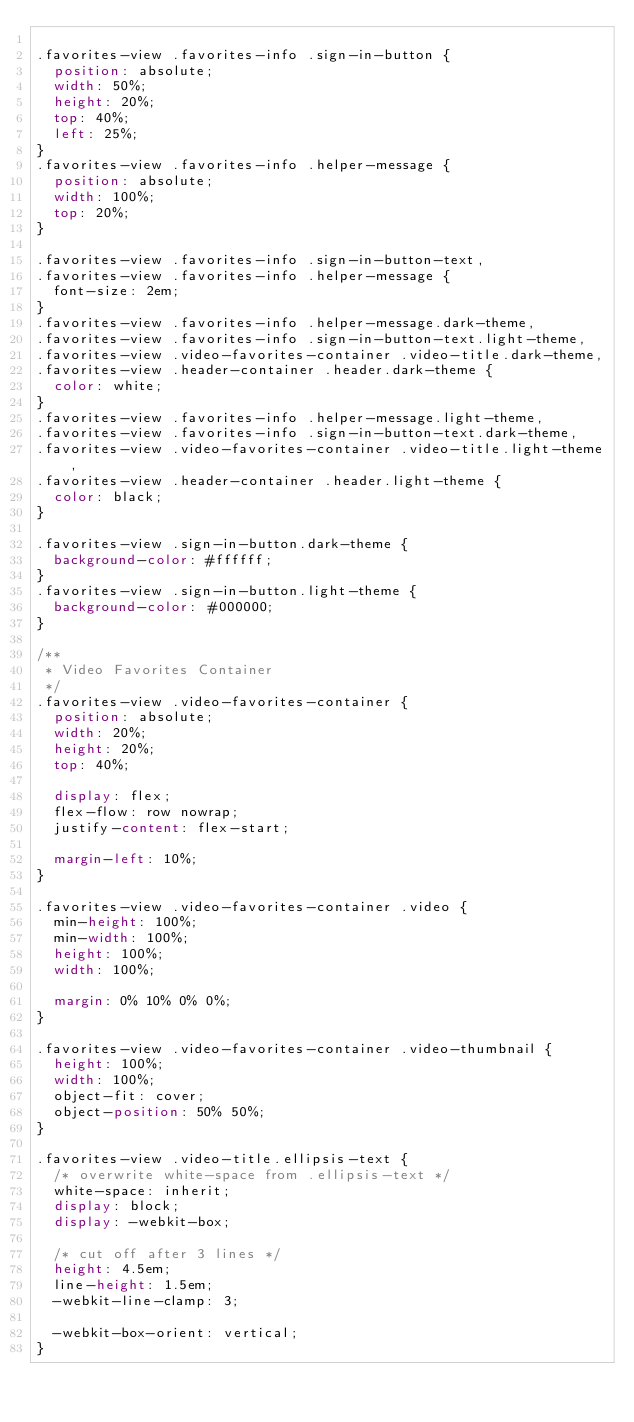Convert code to text. <code><loc_0><loc_0><loc_500><loc_500><_CSS_>
.favorites-view .favorites-info .sign-in-button {
  position: absolute;
  width: 50%;
  height: 20%;
  top: 40%;
  left: 25%;
}
.favorites-view .favorites-info .helper-message {
  position: absolute;
  width: 100%;
  top: 20%;
}

.favorites-view .favorites-info .sign-in-button-text,
.favorites-view .favorites-info .helper-message {
  font-size: 2em;
}
.favorites-view .favorites-info .helper-message.dark-theme,
.favorites-view .favorites-info .sign-in-button-text.light-theme,
.favorites-view .video-favorites-container .video-title.dark-theme,
.favorites-view .header-container .header.dark-theme {
  color: white;
}
.favorites-view .favorites-info .helper-message.light-theme,
.favorites-view .favorites-info .sign-in-button-text.dark-theme,
.favorites-view .video-favorites-container .video-title.light-theme,
.favorites-view .header-container .header.light-theme {
  color: black;
}

.favorites-view .sign-in-button.dark-theme {
  background-color: #ffffff;
}
.favorites-view .sign-in-button.light-theme {
  background-color: #000000;
}

/**
 * Video Favorites Container
 */
.favorites-view .video-favorites-container {
  position: absolute;
  width: 20%;
  height: 20%;
  top: 40%;

  display: flex;
  flex-flow: row nowrap;
  justify-content: flex-start;

  margin-left: 10%;
}

.favorites-view .video-favorites-container .video {
  min-height: 100%;
  min-width: 100%;
  height: 100%;
  width: 100%;

  margin: 0% 10% 0% 0%;
}

.favorites-view .video-favorites-container .video-thumbnail {
  height: 100%;
  width: 100%;
  object-fit: cover;
  object-position: 50% 50%;
}

.favorites-view .video-title.ellipsis-text {
  /* overwrite white-space from .ellipsis-text */
  white-space: inherit;
  display: block;
  display: -webkit-box;

  /* cut off after 3 lines */
  height: 4.5em;
  line-height: 1.5em;
  -webkit-line-clamp: 3;

  -webkit-box-orient: vertical;
}</code> 